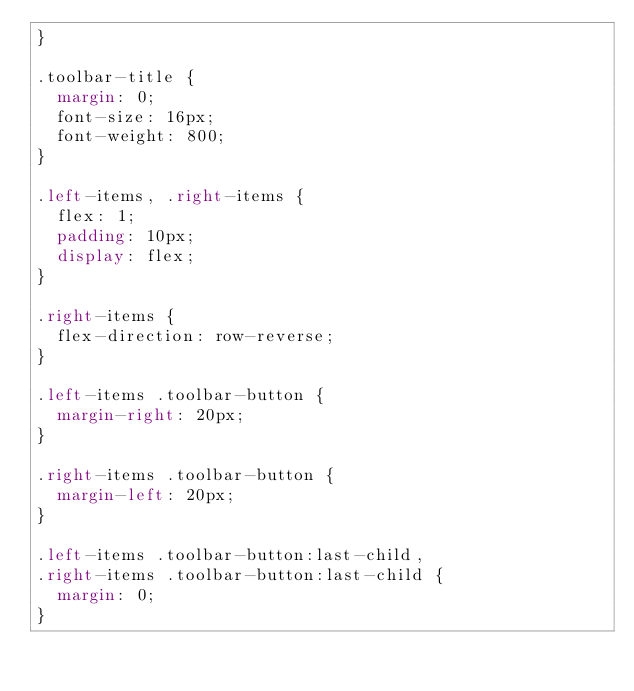<code> <loc_0><loc_0><loc_500><loc_500><_CSS_>}

.toolbar-title {
  margin: 0;
  font-size: 16px;
  font-weight: 800;
}

.left-items, .right-items {
  flex: 1;
  padding: 10px;
  display: flex;
}

.right-items {
  flex-direction: row-reverse;
}

.left-items .toolbar-button {
  margin-right: 20px;
}

.right-items .toolbar-button {
  margin-left: 20px;
}

.left-items .toolbar-button:last-child,
.right-items .toolbar-button:last-child {
  margin: 0;
}</code> 